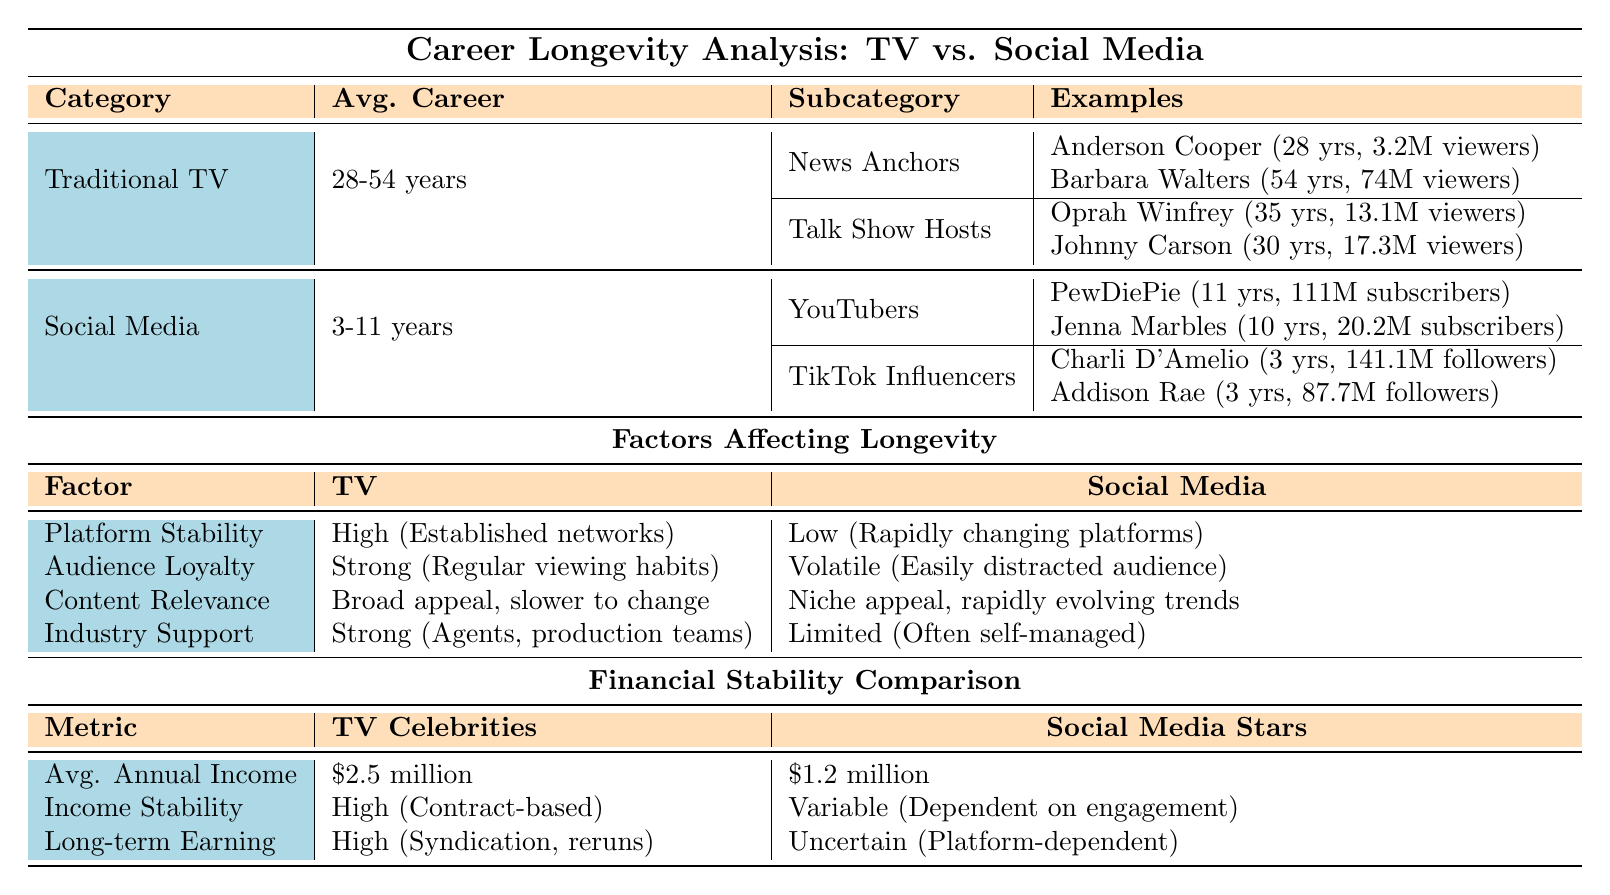What is the average career length of traditional TV celebrities? According to the table, the average career length for traditional TV celebrities is stated as 20.5 years.
Answer: 20.5 years How long is the career length of Barbara Walters? The table lists Barbara Walters' career length as 54 years in the News Anchors subcategory.
Answer: 54 years Which category has a higher average career length, TV celebrities or social media stars? The average career length for TV celebrities is 20.5 years, while for social media stars, it is 5.3 years. Therefore, TV celebrities have a higher average length.
Answer: TV celebrities What is the peak viewership of Oprah Winfrey? The peak viewership for Oprah Winfrey, listed under Talk Show Hosts, is 13.1 million.
Answer: 13.1 million How many years has PewDiePie been active? PewDiePie has been active for 11 years as indicated in the YouTubers subcategory.
Answer: 11 years Is the income stability for TV celebrities classified as high? The table specifies that the income stability for TV celebrities is classified as high, consistent with having contract-based income.
Answer: Yes What is the total average career length of both news anchors and talk show hosts combined? News Anchors have an average career of 41 years (28 + 54) and Talk Show Hosts have an average of 32.5 years (35 + 30). Adding both averages (41 + 32.5) gives a total of 73.5 years.
Answer: 73.5 years Which factor shows that traditional TV celebrities have more industry support than social media stars? The table indicates that TV celebrities have strong industry support (agents, production teams), while social media stars have limited support.
Answer: Yes How does the average annual income of social media stars compare to that of TV celebrities? The average annual income for TV celebrities is $2.5 million, while for social media stars, it is $1.2 million. This shows that TV celebrities have a higher average annual income.
Answer: Higher for TV celebrities What can be inferred about the audience loyalty between TV and social media platforms? The table states that audience loyalty for TV is strong and regular, while for social media, it is volatile, indicating that TV has a more dedicated audience.
Answer: TV has more dedicated audience What is the difference in income stability between TV celebrities and social media stars? TV celebrities have high income stability, while social media stars have variable income, showing a significant difference in their income stability.
Answer: Significant difference 